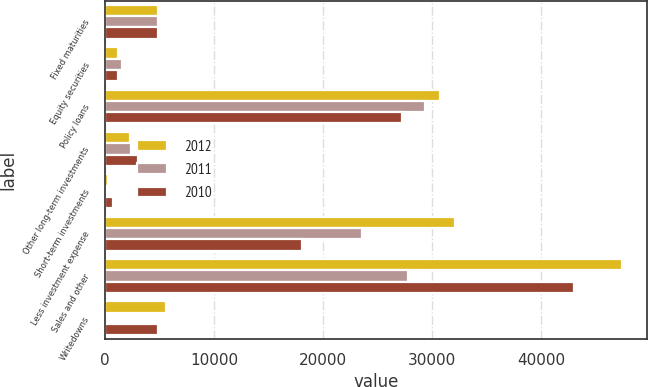<chart> <loc_0><loc_0><loc_500><loc_500><stacked_bar_chart><ecel><fcel>Fixed maturities<fcel>Equity securities<fcel>Policy loans<fcel>Other long-term investments<fcel>Short-term investments<fcel>Less investment expense<fcel>Sales and other<fcel>Writedowns<nl><fcel>2012<fcel>4850<fcel>1178<fcel>30717<fcel>2320<fcel>311<fcel>32111<fcel>47345<fcel>5600<nl><fcel>2011<fcel>4850<fcel>1558<fcel>29293<fcel>2439<fcel>165<fcel>23528<fcel>27790<fcel>20<nl><fcel>2010<fcel>4850<fcel>1183<fcel>27248<fcel>3064<fcel>762<fcel>18095<fcel>43022<fcel>4850<nl></chart> 